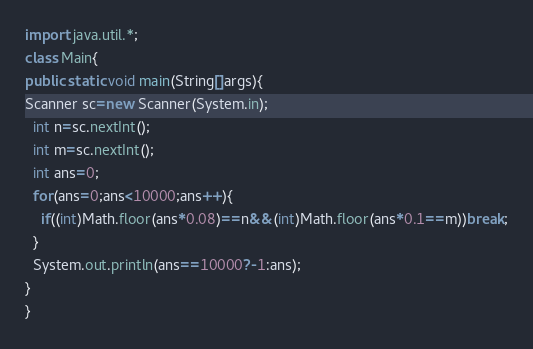<code> <loc_0><loc_0><loc_500><loc_500><_Java_>import java.util.*;
class Main{
public static void main(String[]args){
Scanner sc=new Scanner(System.in);
  int n=sc.nextInt();
  int m=sc.nextInt();
  int ans=0;
  for(ans=0;ans<10000;ans++){
  	if((int)Math.floor(ans*0.08)==n&&(int)Math.floor(ans*0.1==m))break;
  }
  System.out.println(ans==10000?-1:ans);
}
}
</code> 